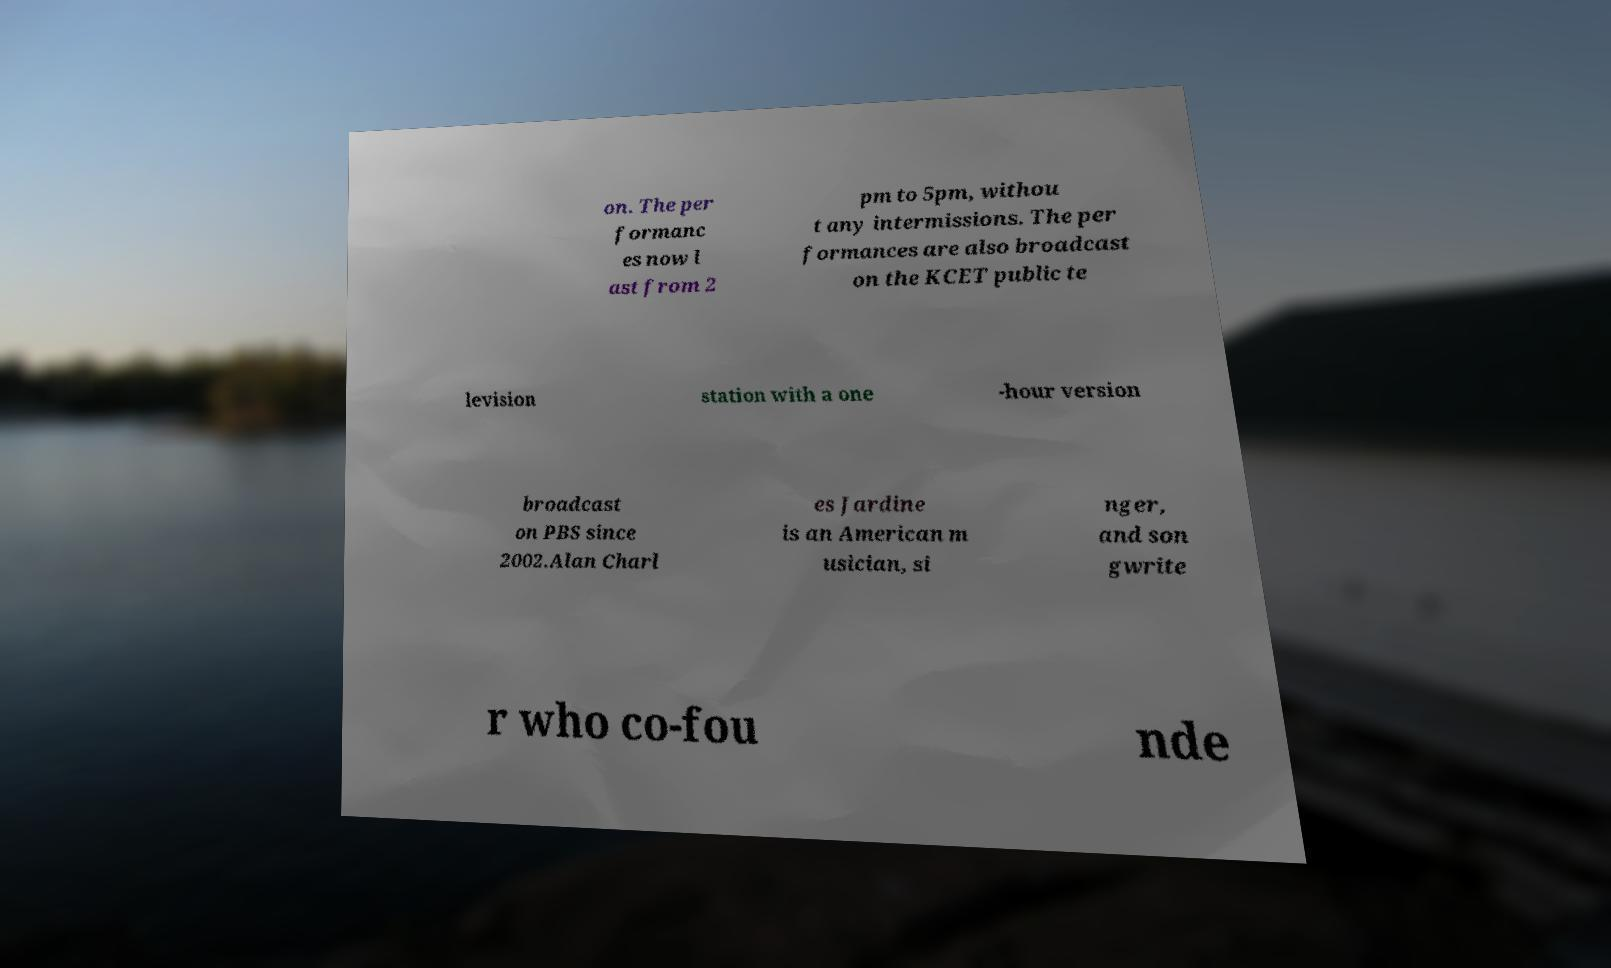Can you read and provide the text displayed in the image?This photo seems to have some interesting text. Can you extract and type it out for me? on. The per formanc es now l ast from 2 pm to 5pm, withou t any intermissions. The per formances are also broadcast on the KCET public te levision station with a one -hour version broadcast on PBS since 2002.Alan Charl es Jardine is an American m usician, si nger, and son gwrite r who co-fou nde 